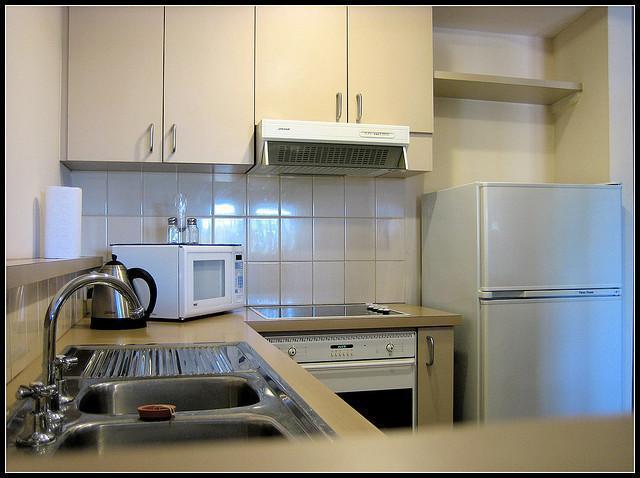How many handles are visible?
Give a very brief answer. 5. How many sinks are there?
Give a very brief answer. 2. How many people are not wearing goggles?
Give a very brief answer. 0. 